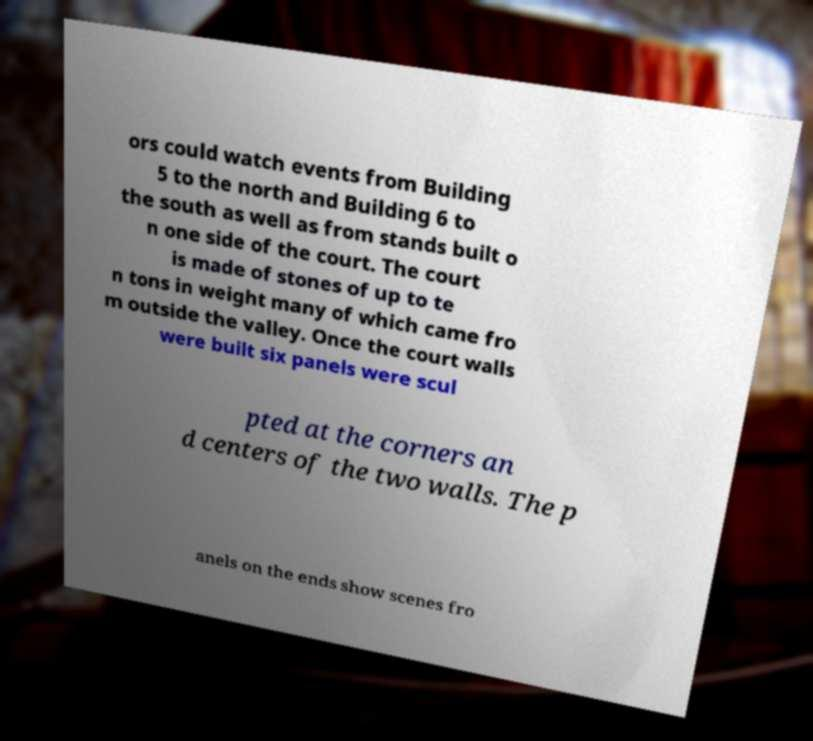Please identify and transcribe the text found in this image. ors could watch events from Building 5 to the north and Building 6 to the south as well as from stands built o n one side of the court. The court is made of stones of up to te n tons in weight many of which came fro m outside the valley. Once the court walls were built six panels were scul pted at the corners an d centers of the two walls. The p anels on the ends show scenes fro 